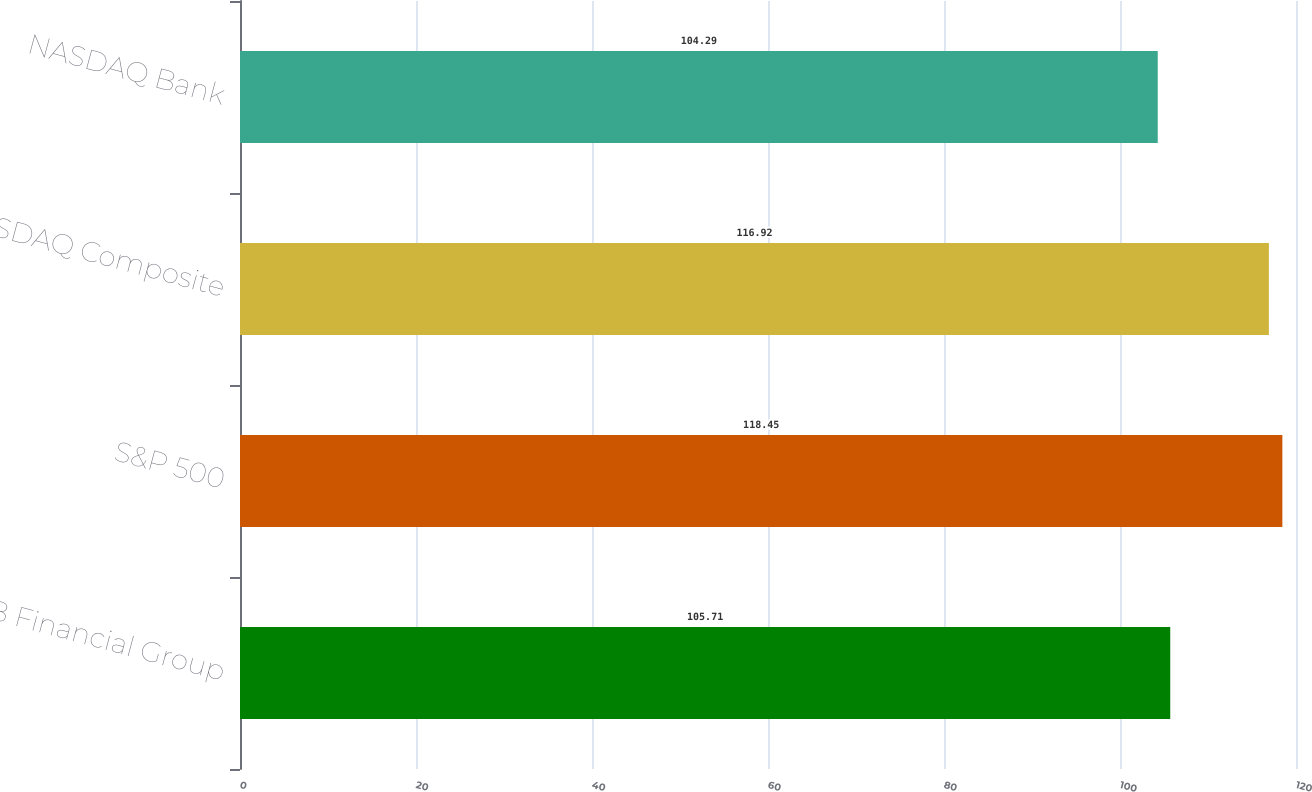<chart> <loc_0><loc_0><loc_500><loc_500><bar_chart><fcel>SVB Financial Group<fcel>S&P 500<fcel>NASDAQ Composite<fcel>NASDAQ Bank<nl><fcel>105.71<fcel>118.45<fcel>116.92<fcel>104.29<nl></chart> 